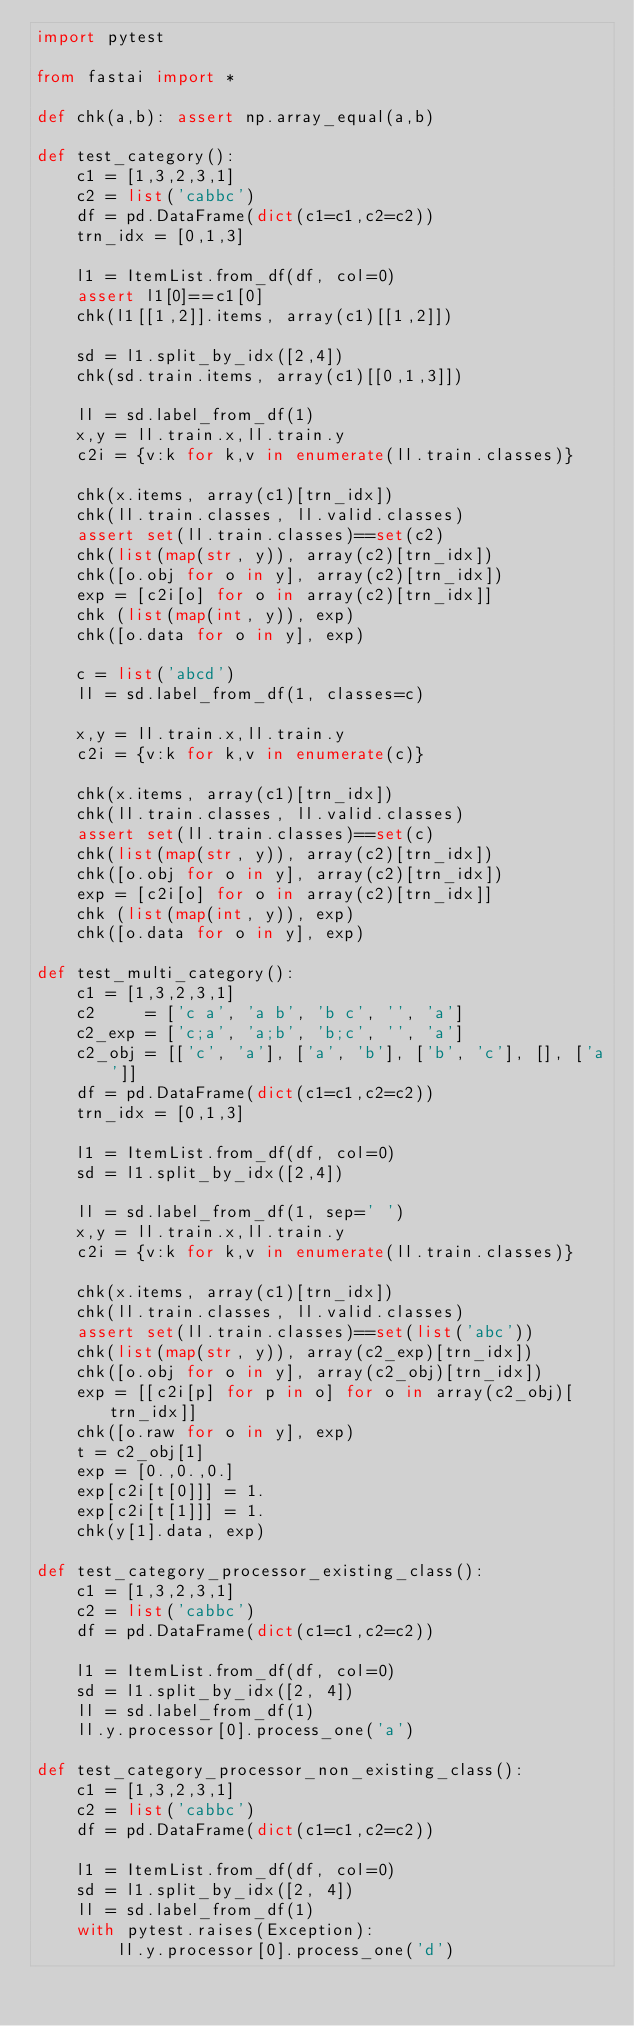<code> <loc_0><loc_0><loc_500><loc_500><_Python_>import pytest

from fastai import *

def chk(a,b): assert np.array_equal(a,b)

def test_category():
    c1 = [1,3,2,3,1]
    c2 = list('cabbc')
    df = pd.DataFrame(dict(c1=c1,c2=c2))
    trn_idx = [0,1,3]

    l1 = ItemList.from_df(df, col=0)
    assert l1[0]==c1[0]
    chk(l1[[1,2]].items, array(c1)[[1,2]])

    sd = l1.split_by_idx([2,4])
    chk(sd.train.items, array(c1)[[0,1,3]])

    ll = sd.label_from_df(1)
    x,y = ll.train.x,ll.train.y
    c2i = {v:k for k,v in enumerate(ll.train.classes)}

    chk(x.items, array(c1)[trn_idx])
    chk(ll.train.classes, ll.valid.classes)
    assert set(ll.train.classes)==set(c2)
    chk(list(map(str, y)), array(c2)[trn_idx])
    chk([o.obj for o in y], array(c2)[trn_idx])
    exp = [c2i[o] for o in array(c2)[trn_idx]]
    chk (list(map(int, y)), exp)
    chk([o.data for o in y], exp)

    c = list('abcd')
    ll = sd.label_from_df(1, classes=c)

    x,y = ll.train.x,ll.train.y
    c2i = {v:k for k,v in enumerate(c)}

    chk(x.items, array(c1)[trn_idx])
    chk(ll.train.classes, ll.valid.classes)
    assert set(ll.train.classes)==set(c)
    chk(list(map(str, y)), array(c2)[trn_idx])
    chk([o.obj for o in y], array(c2)[trn_idx])
    exp = [c2i[o] for o in array(c2)[trn_idx]]
    chk (list(map(int, y)), exp)
    chk([o.data for o in y], exp)

def test_multi_category():
    c1 = [1,3,2,3,1]
    c2     = ['c a', 'a b', 'b c', '', 'a']
    c2_exp = ['c;a', 'a;b', 'b;c', '', 'a']
    c2_obj = [['c', 'a'], ['a', 'b'], ['b', 'c'], [], ['a']]
    df = pd.DataFrame(dict(c1=c1,c2=c2))
    trn_idx = [0,1,3]

    l1 = ItemList.from_df(df, col=0)
    sd = l1.split_by_idx([2,4])

    ll = sd.label_from_df(1, sep=' ')
    x,y = ll.train.x,ll.train.y
    c2i = {v:k for k,v in enumerate(ll.train.classes)}

    chk(x.items, array(c1)[trn_idx])
    chk(ll.train.classes, ll.valid.classes)
    assert set(ll.train.classes)==set(list('abc'))
    chk(list(map(str, y)), array(c2_exp)[trn_idx])
    chk([o.obj for o in y], array(c2_obj)[trn_idx])
    exp = [[c2i[p] for p in o] for o in array(c2_obj)[trn_idx]]
    chk([o.raw for o in y], exp)
    t = c2_obj[1]
    exp = [0.,0.,0.]
    exp[c2i[t[0]]] = 1.
    exp[c2i[t[1]]] = 1.
    chk(y[1].data, exp)

def test_category_processor_existing_class():
    c1 = [1,3,2,3,1]
    c2 = list('cabbc')
    df = pd.DataFrame(dict(c1=c1,c2=c2))

    l1 = ItemList.from_df(df, col=0)
    sd = l1.split_by_idx([2, 4])
    ll = sd.label_from_df(1)
    ll.y.processor[0].process_one('a')

def test_category_processor_non_existing_class():
    c1 = [1,3,2,3,1]
    c2 = list('cabbc')
    df = pd.DataFrame(dict(c1=c1,c2=c2))

    l1 = ItemList.from_df(df, col=0)
    sd = l1.split_by_idx([2, 4])
    ll = sd.label_from_df(1)
    with pytest.raises(Exception):
        ll.y.processor[0].process_one('d')</code> 